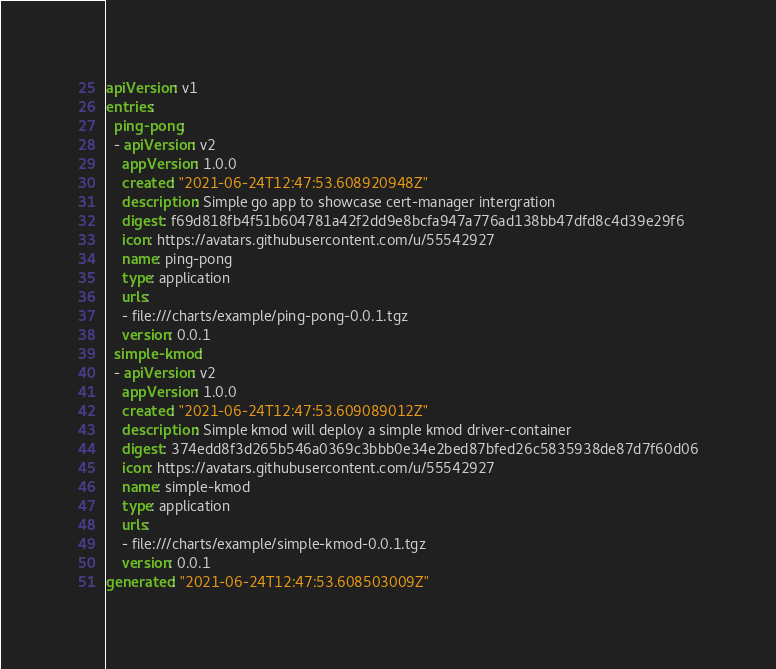<code> <loc_0><loc_0><loc_500><loc_500><_YAML_>apiVersion: v1
entries:
  ping-pong:
  - apiVersion: v2
    appVersion: 1.0.0
    created: "2021-06-24T12:47:53.608920948Z"
    description: Simple go app to showcase cert-manager intergration
    digest: f69d818fb4f51b604781a42f2dd9e8bcfa947a776ad138bb47dfd8c4d39e29f6
    icon: https://avatars.githubusercontent.com/u/55542927
    name: ping-pong
    type: application
    urls:
    - file:///charts/example/ping-pong-0.0.1.tgz
    version: 0.0.1
  simple-kmod:
  - apiVersion: v2
    appVersion: 1.0.0
    created: "2021-06-24T12:47:53.609089012Z"
    description: Simple kmod will deploy a simple kmod driver-container
    digest: 374edd8f3d265b546a0369c3bbb0e34e2bed87bfed26c5835938de87d7f60d06
    icon: https://avatars.githubusercontent.com/u/55542927
    name: simple-kmod
    type: application
    urls:
    - file:///charts/example/simple-kmod-0.0.1.tgz
    version: 0.0.1
generated: "2021-06-24T12:47:53.608503009Z"
</code> 